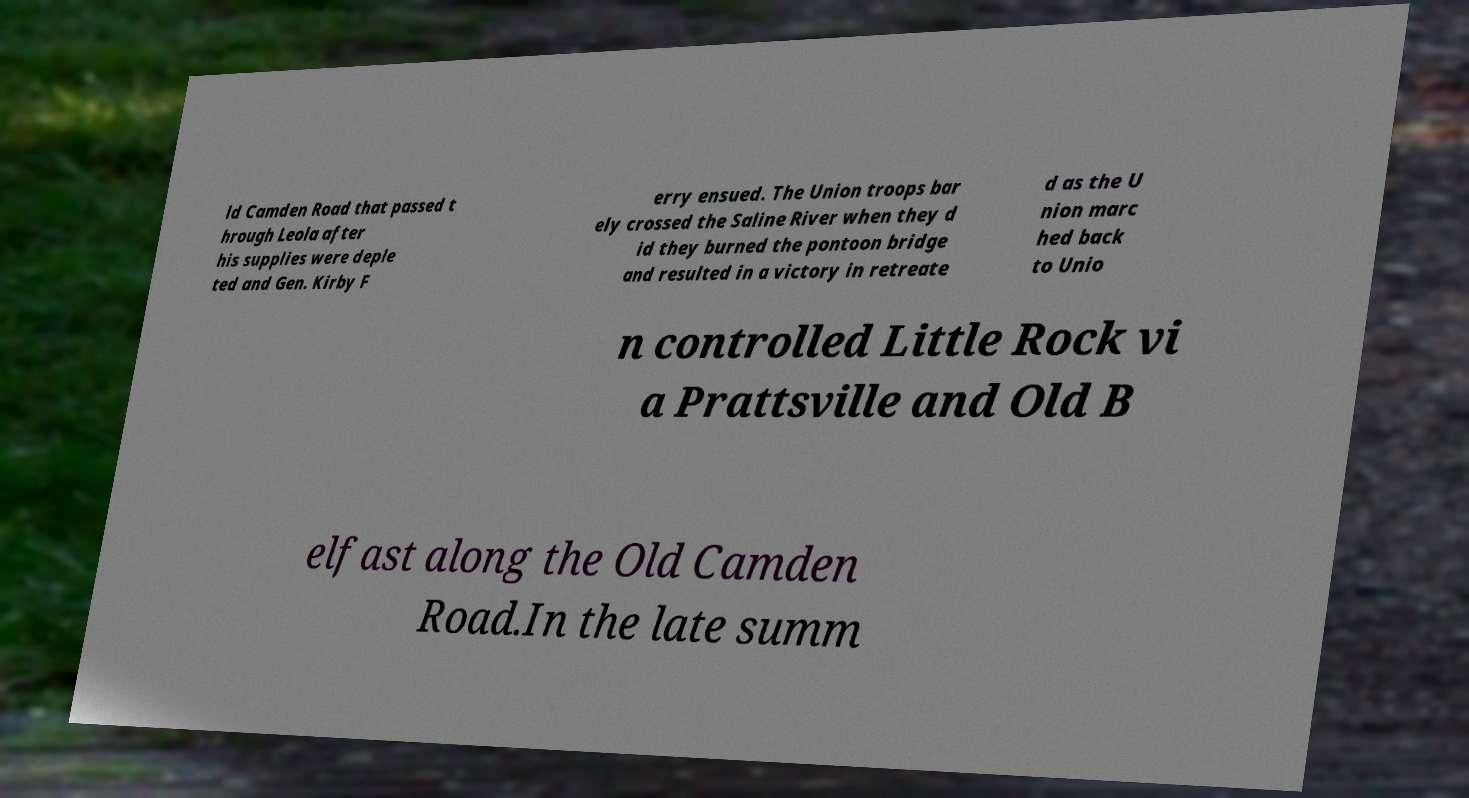Can you accurately transcribe the text from the provided image for me? ld Camden Road that passed t hrough Leola after his supplies were deple ted and Gen. Kirby F erry ensued. The Union troops bar ely crossed the Saline River when they d id they burned the pontoon bridge and resulted in a victory in retreate d as the U nion marc hed back to Unio n controlled Little Rock vi a Prattsville and Old B elfast along the Old Camden Road.In the late summ 